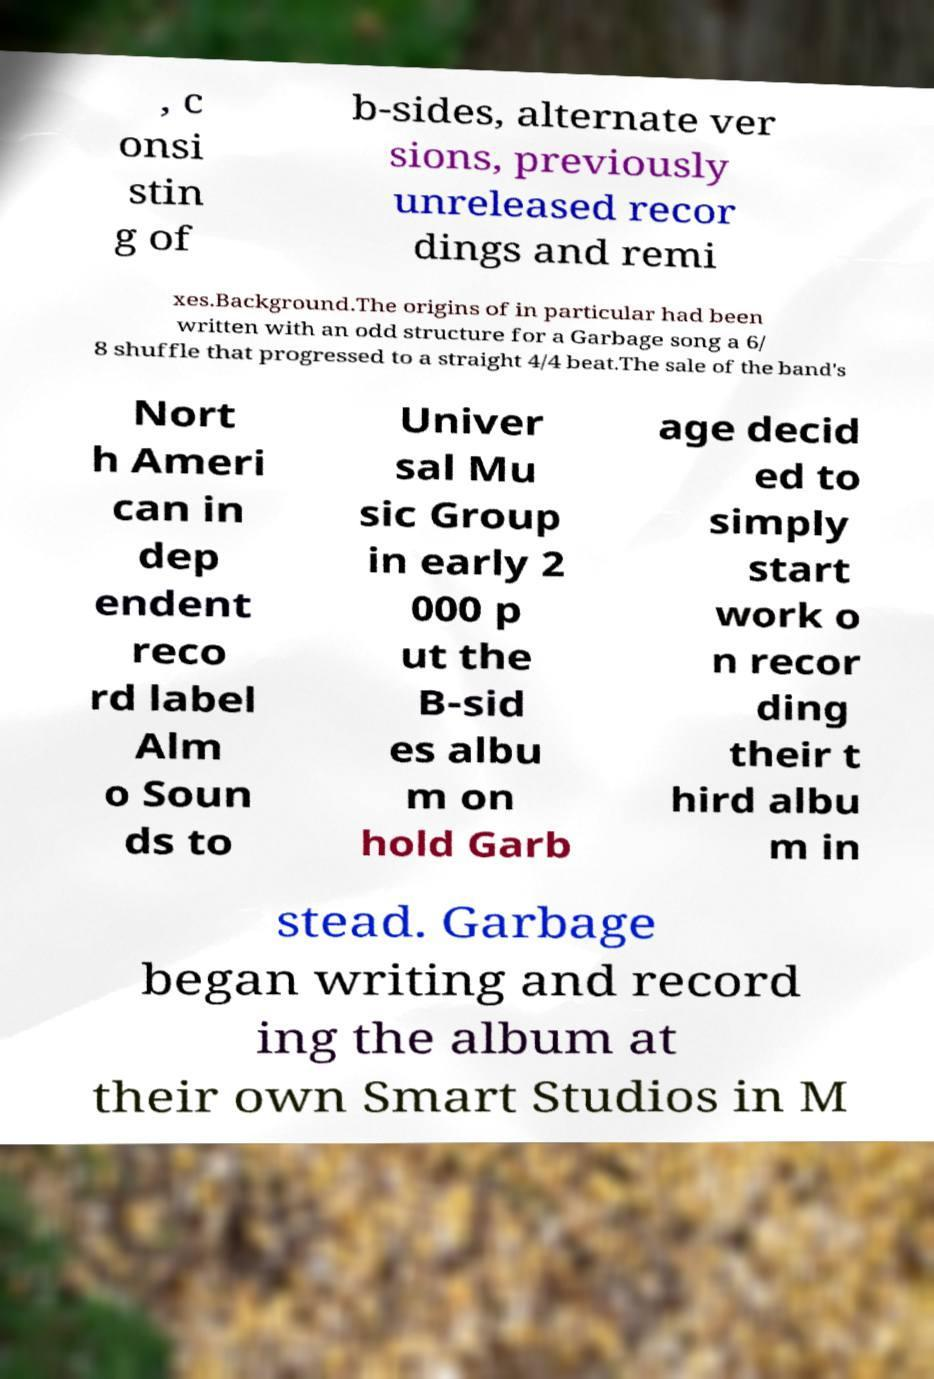There's text embedded in this image that I need extracted. Can you transcribe it verbatim? , c onsi stin g of b-sides, alternate ver sions, previously unreleased recor dings and remi xes.Background.The origins of in particular had been written with an odd structure for a Garbage song a 6/ 8 shuffle that progressed to a straight 4/4 beat.The sale of the band's Nort h Ameri can in dep endent reco rd label Alm o Soun ds to Univer sal Mu sic Group in early 2 000 p ut the B-sid es albu m on hold Garb age decid ed to simply start work o n recor ding their t hird albu m in stead. Garbage began writing and record ing the album at their own Smart Studios in M 